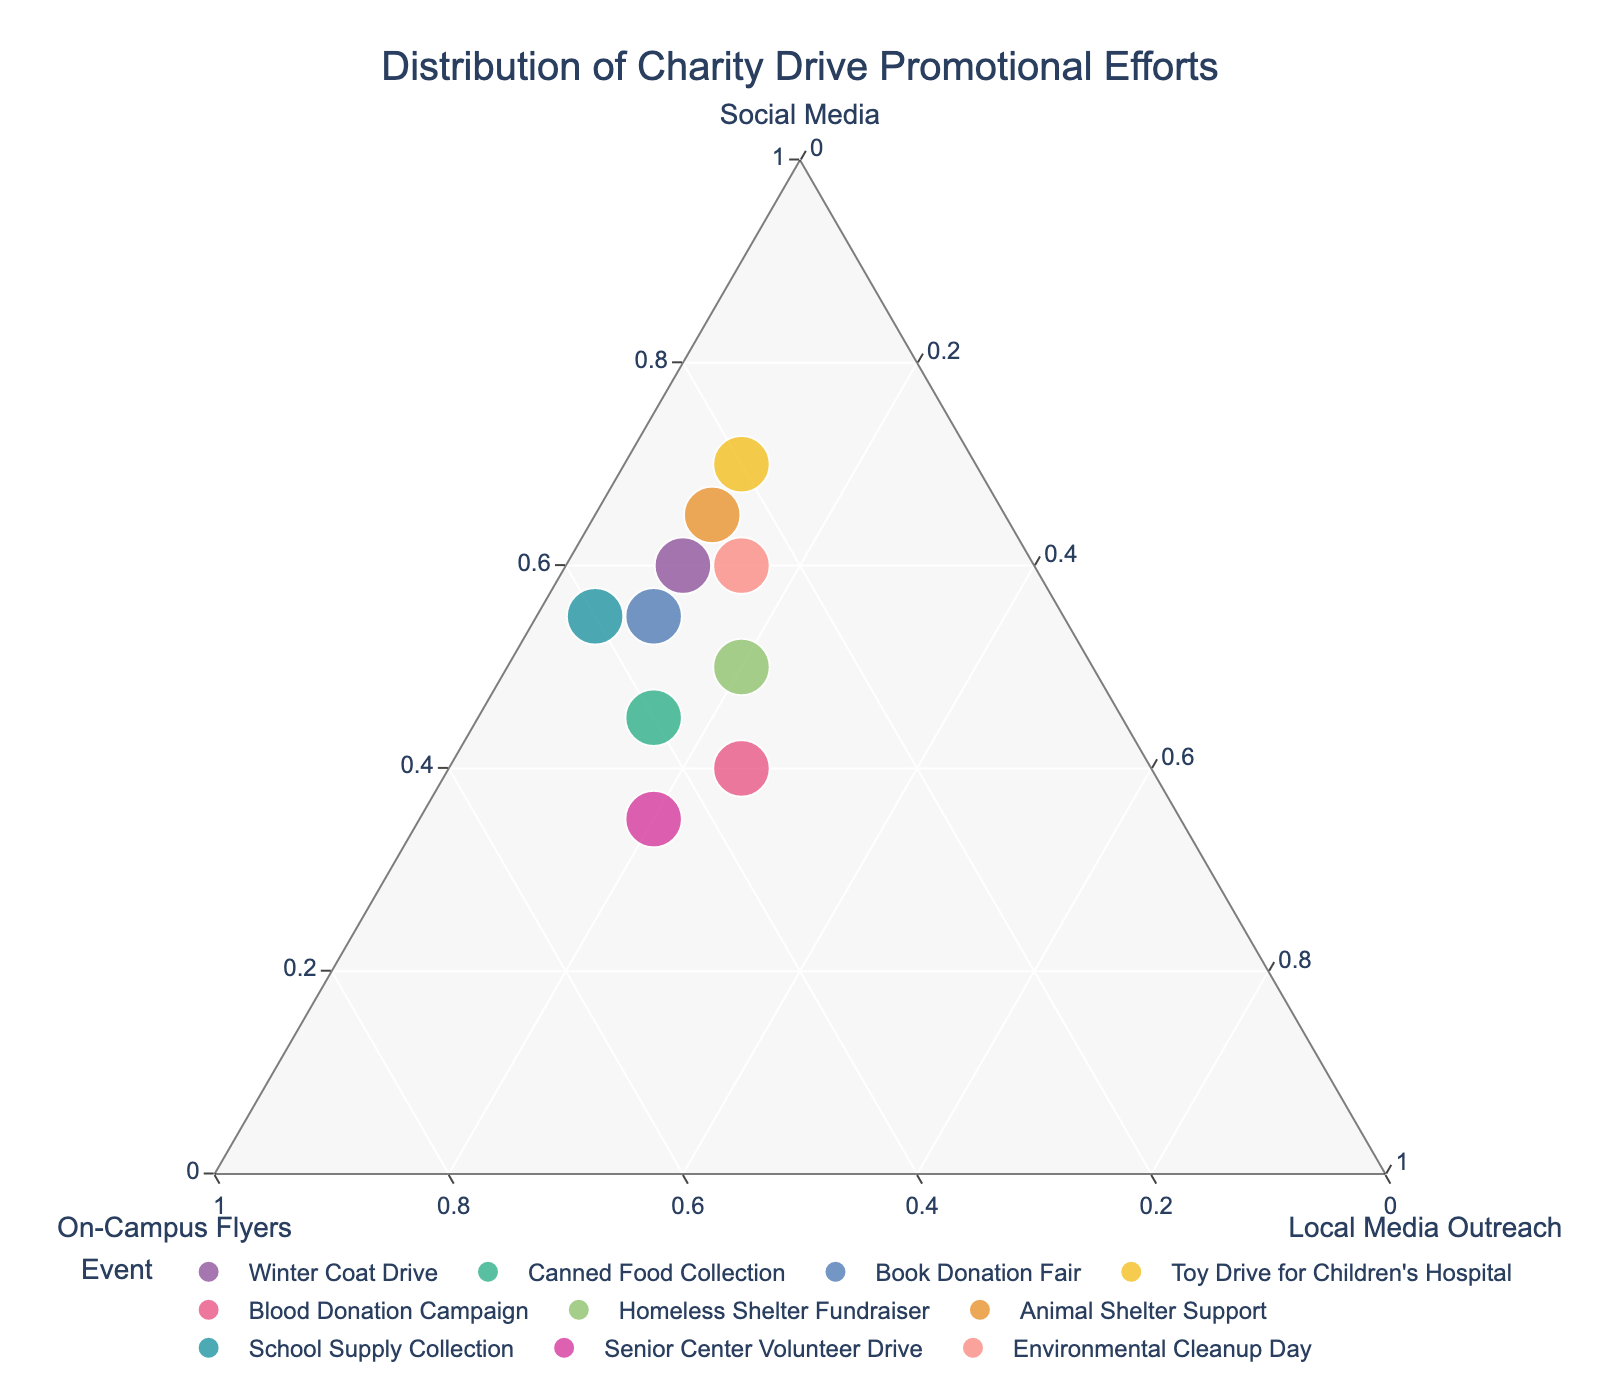what is the title of the plot? The title of the plot is located at the top center and provides an overview of what the figure represents. In this case, the title indicates the distribution of promotional efforts for charity drives.
Answer: Distribution of Charity Drive Promotional Efforts How many charity drive events are depicted in the plot? To determine the number of events, look at the number of data points or unique labels in the legend. Each point or label represents a different event.
Answer: 10 Which event has the highest percentage of efforts in social media promotion? Observe the points positioned closer to the social media vertex. The event with the highest social media effort will be closest to this corner.
Answer: Toy Drive for Children's Hospital Which events have an equal percentage effort for local media outreach? Look for points that lie along the same line parallel to the axis opposite the local media vertex. These events will have the same local media outreach percentage.
Answer: Winter Coat Drive, Book Donation Fair, Toy Drive for Children's Hospital, Animal Shelter Support Which event shows the most balanced distribution across all three platforms? Identify the point closest to the center of the triangle, where the distances to all three vertices (social media, flyers, local media) are approximately equal.
Answer: Blood Donation Campaign What is the average percentage of flyer-based promotional efforts across all events? Calculate this by summing up the percentages for flyers for all events, then dividing by the number of events. Flyers = (30+40+35+20+35+30+25+40+45+25)/10 = 325. Average = 325/10 = 32.5%
Answer: 32.5% Between "School Supply Collection" and "Environmental Cleanup Day," which event used more social media efforts? Compare the positions of these two events relative to the social media vertex. The one closer to this corner had more social media efforts.
Answer: Environmental Cleanup Day For "Senior Center Volunteer Drive," what are the approximate percentages for each promotional effort? Check the exact positions of the point labeled "Senior Center Volunteer Drive" and note the respective distances to the three vertices to estimate the percentages.
Answer: Social Media: 35%, Flyers: 45%, Local Media: 20% True or False: "Canned Food Collection" had a higher percentage of efforts on flyers than "Homeless Shelter Fundraiser." By comparing the positions of these two events relative to the flyers vertex, one can determine if this statement is correct or not.
Answer: True What trend can be observed about the use of local media outreach across all events? By evaluating the general spread of the points in relation to the local media vertex, one can determine if there are any visible trends or patterns.
Answer: Local Media is less utilized compared to Social Media and Flyers 